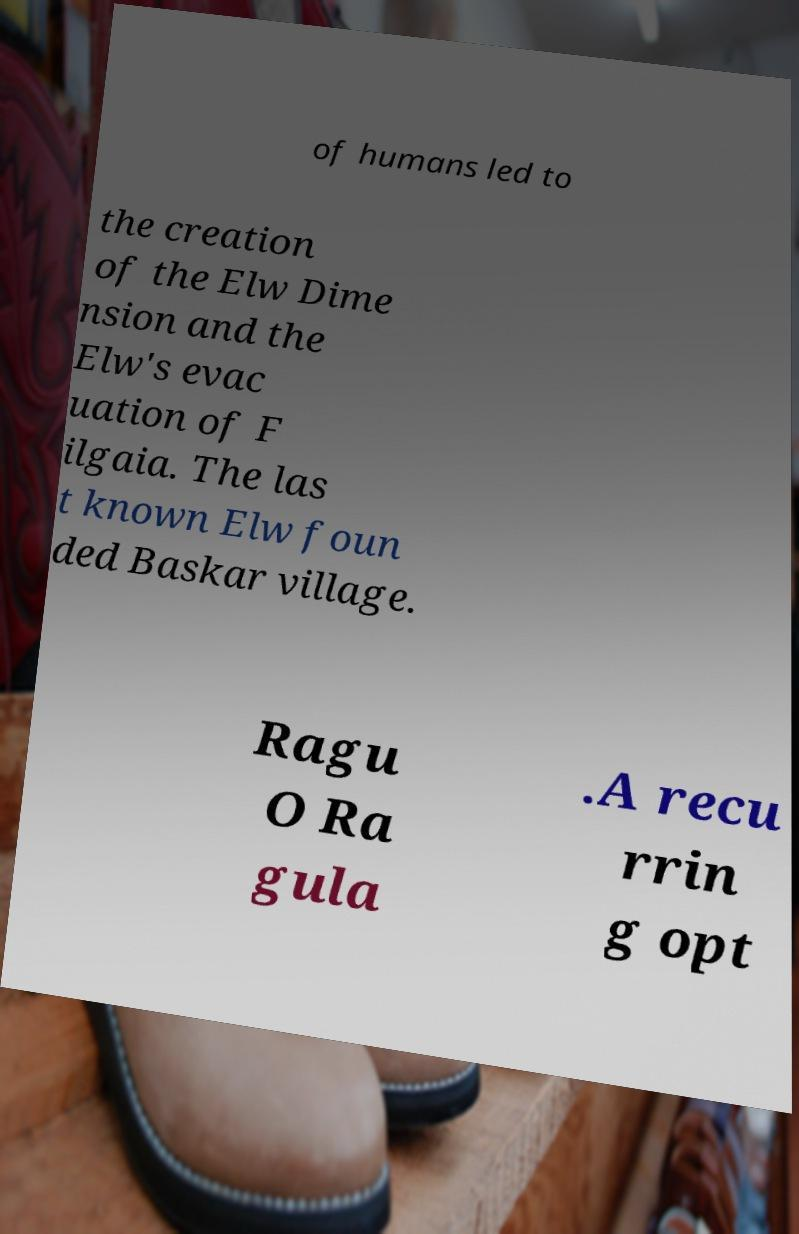Could you extract and type out the text from this image? of humans led to the creation of the Elw Dime nsion and the Elw's evac uation of F ilgaia. The las t known Elw foun ded Baskar village. Ragu O Ra gula .A recu rrin g opt 